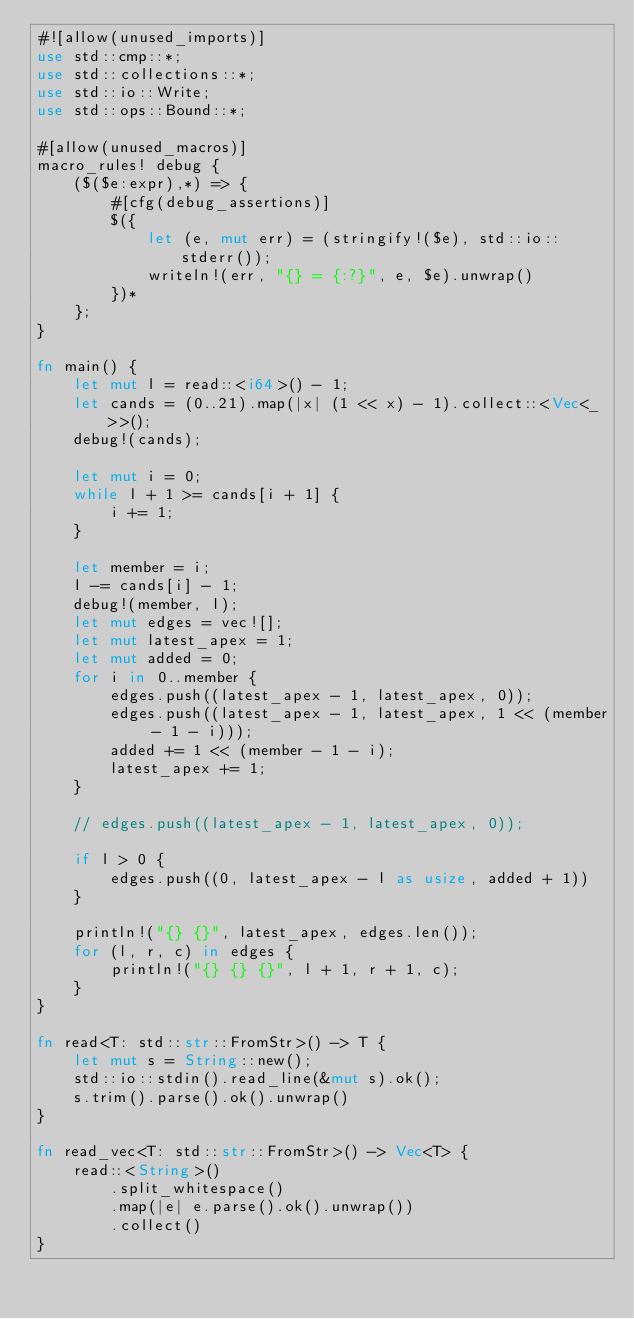<code> <loc_0><loc_0><loc_500><loc_500><_Rust_>#![allow(unused_imports)]
use std::cmp::*;
use std::collections::*;
use std::io::Write;
use std::ops::Bound::*;

#[allow(unused_macros)]
macro_rules! debug {
    ($($e:expr),*) => {
        #[cfg(debug_assertions)]
        $({
            let (e, mut err) = (stringify!($e), std::io::stderr());
            writeln!(err, "{} = {:?}", e, $e).unwrap()
        })*
    };
}

fn main() {
    let mut l = read::<i64>() - 1;
    let cands = (0..21).map(|x| (1 << x) - 1).collect::<Vec<_>>();
    debug!(cands);

    let mut i = 0;
    while l + 1 >= cands[i + 1] {
        i += 1;
    }

    let member = i;
    l -= cands[i] - 1;
    debug!(member, l);
    let mut edges = vec![];
    let mut latest_apex = 1;
    let mut added = 0;
    for i in 0..member {
        edges.push((latest_apex - 1, latest_apex, 0));
        edges.push((latest_apex - 1, latest_apex, 1 << (member - 1 - i)));
        added += 1 << (member - 1 - i);
        latest_apex += 1;
    }

    // edges.push((latest_apex - 1, latest_apex, 0));

    if l > 0 {
        edges.push((0, latest_apex - l as usize, added + 1))
    }

    println!("{} {}", latest_apex, edges.len());
    for (l, r, c) in edges {
        println!("{} {} {}", l + 1, r + 1, c);
    }
}

fn read<T: std::str::FromStr>() -> T {
    let mut s = String::new();
    std::io::stdin().read_line(&mut s).ok();
    s.trim().parse().ok().unwrap()
}

fn read_vec<T: std::str::FromStr>() -> Vec<T> {
    read::<String>()
        .split_whitespace()
        .map(|e| e.parse().ok().unwrap())
        .collect()
}
</code> 